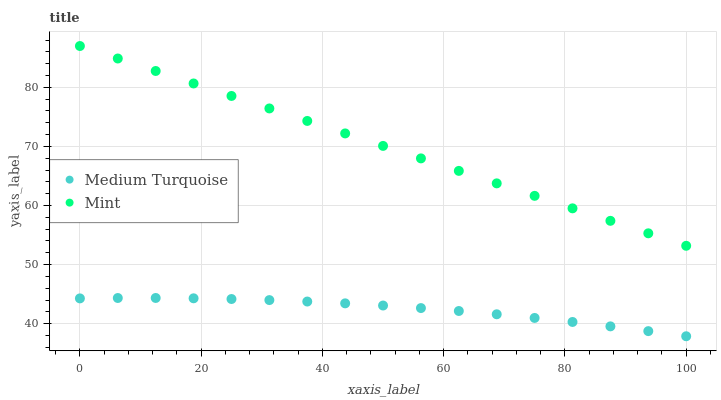Does Medium Turquoise have the minimum area under the curve?
Answer yes or no. Yes. Does Mint have the maximum area under the curve?
Answer yes or no. Yes. Does Medium Turquoise have the maximum area under the curve?
Answer yes or no. No. Is Mint the smoothest?
Answer yes or no. Yes. Is Medium Turquoise the roughest?
Answer yes or no. Yes. Is Medium Turquoise the smoothest?
Answer yes or no. No. Does Medium Turquoise have the lowest value?
Answer yes or no. Yes. Does Mint have the highest value?
Answer yes or no. Yes. Does Medium Turquoise have the highest value?
Answer yes or no. No. Is Medium Turquoise less than Mint?
Answer yes or no. Yes. Is Mint greater than Medium Turquoise?
Answer yes or no. Yes. Does Medium Turquoise intersect Mint?
Answer yes or no. No. 